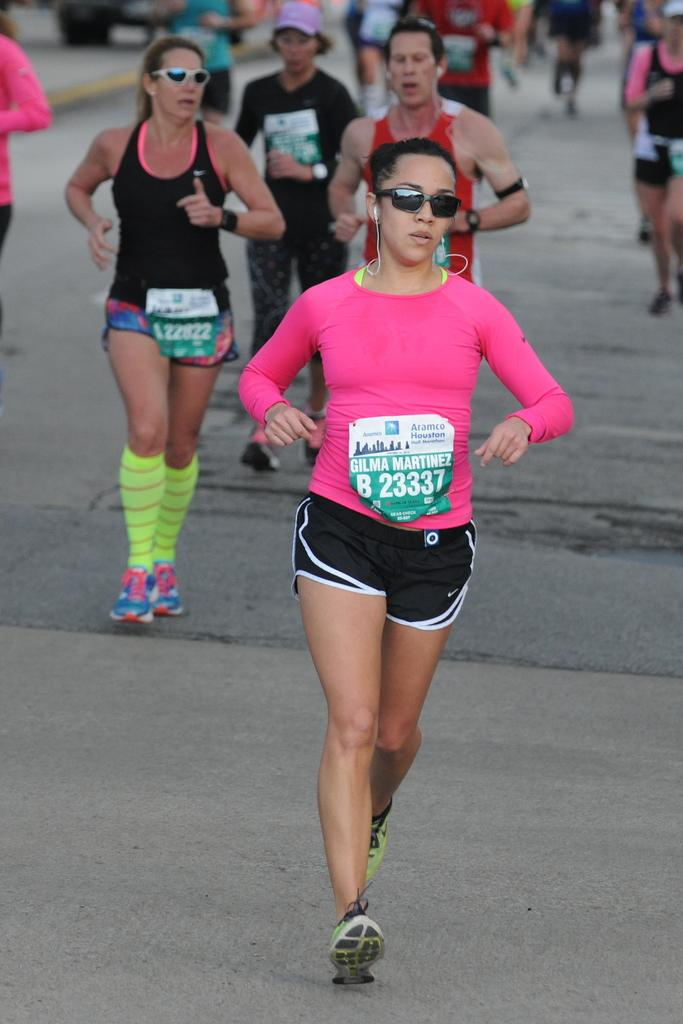Who or what can be seen in the image? There are people in the image. What are the people doing in the image? The people are running on the road. What type of cake is being served to the people running on the road? There is no cake present in the image; the people are running on the road without any food or beverages. 